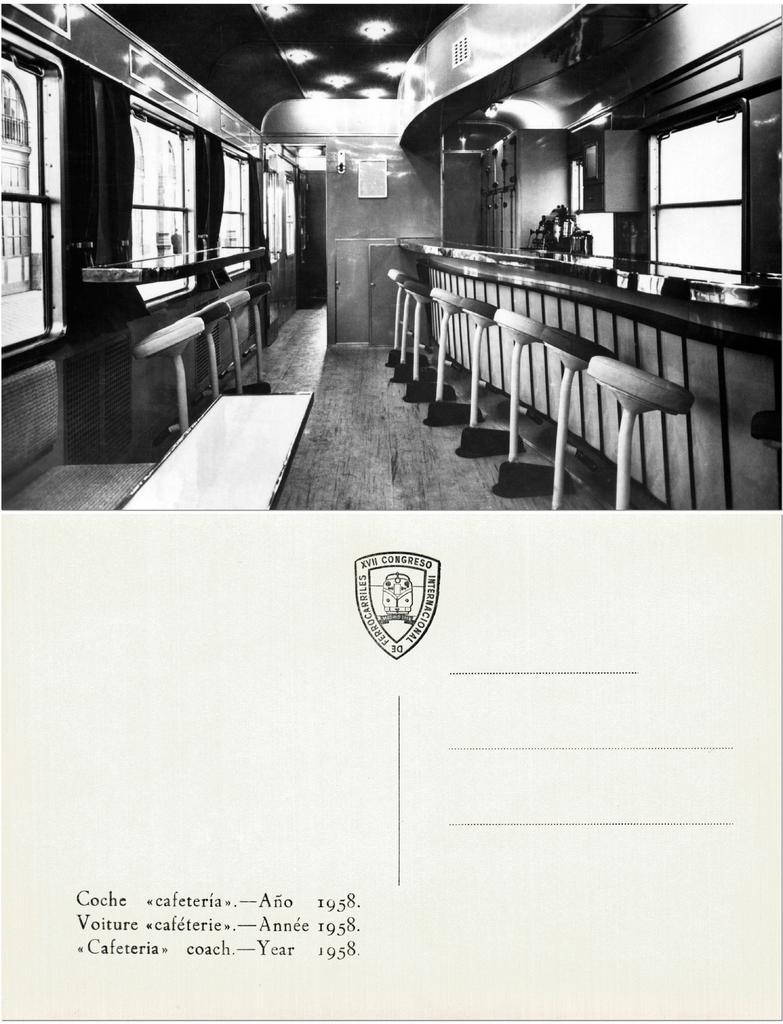Describe this image in one or two sentences. It is a poster. In this image there are chairs. There are flower pots on the platform. There are glass windows. There is a photo frame on the wall. On top of the image there are lights. At the bottom of the image there is some object on the floor. There are some text, numbers and a picture on the image. 